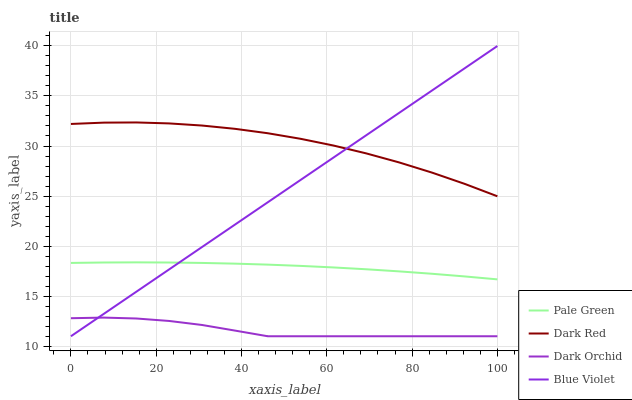Does Dark Orchid have the minimum area under the curve?
Answer yes or no. Yes. Does Dark Red have the maximum area under the curve?
Answer yes or no. Yes. Does Pale Green have the minimum area under the curve?
Answer yes or no. No. Does Pale Green have the maximum area under the curve?
Answer yes or no. No. Is Blue Violet the smoothest?
Answer yes or no. Yes. Is Dark Red the roughest?
Answer yes or no. Yes. Is Pale Green the smoothest?
Answer yes or no. No. Is Pale Green the roughest?
Answer yes or no. No. Does Blue Violet have the lowest value?
Answer yes or no. Yes. Does Pale Green have the lowest value?
Answer yes or no. No. Does Blue Violet have the highest value?
Answer yes or no. Yes. Does Pale Green have the highest value?
Answer yes or no. No. Is Pale Green less than Dark Red?
Answer yes or no. Yes. Is Pale Green greater than Dark Orchid?
Answer yes or no. Yes. Does Dark Red intersect Blue Violet?
Answer yes or no. Yes. Is Dark Red less than Blue Violet?
Answer yes or no. No. Is Dark Red greater than Blue Violet?
Answer yes or no. No. Does Pale Green intersect Dark Red?
Answer yes or no. No. 